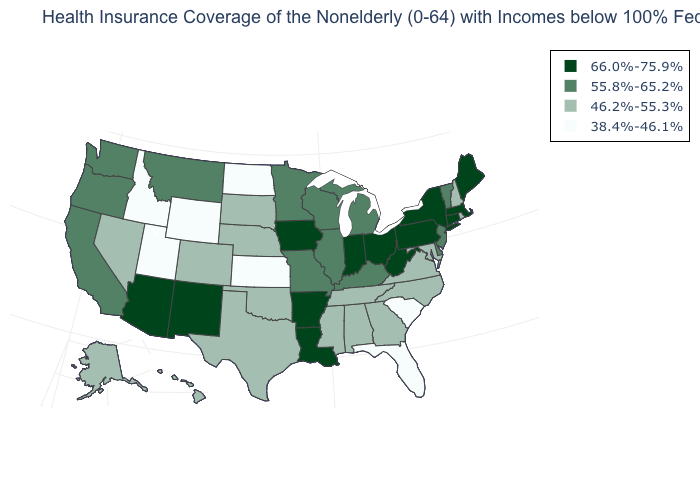Does the first symbol in the legend represent the smallest category?
Give a very brief answer. No. What is the value of Maine?
Quick response, please. 66.0%-75.9%. Name the states that have a value in the range 38.4%-46.1%?
Give a very brief answer. Florida, Idaho, Kansas, North Dakota, South Carolina, Utah, Wyoming. What is the lowest value in the USA?
Write a very short answer. 38.4%-46.1%. Does Delaware have the highest value in the South?
Keep it brief. No. Name the states that have a value in the range 66.0%-75.9%?
Be succinct. Arizona, Arkansas, Connecticut, Indiana, Iowa, Louisiana, Maine, Massachusetts, New Mexico, New York, Ohio, Pennsylvania, West Virginia. Does the first symbol in the legend represent the smallest category?
Short answer required. No. What is the value of Montana?
Write a very short answer. 55.8%-65.2%. Does Indiana have the highest value in the USA?
Short answer required. Yes. What is the highest value in the West ?
Short answer required. 66.0%-75.9%. Among the states that border Massachusetts , which have the highest value?
Short answer required. Connecticut, New York. Does New Jersey have the highest value in the Northeast?
Answer briefly. No. Name the states that have a value in the range 38.4%-46.1%?
Short answer required. Florida, Idaho, Kansas, North Dakota, South Carolina, Utah, Wyoming. Name the states that have a value in the range 38.4%-46.1%?
Answer briefly. Florida, Idaho, Kansas, North Dakota, South Carolina, Utah, Wyoming. Does the map have missing data?
Quick response, please. No. 